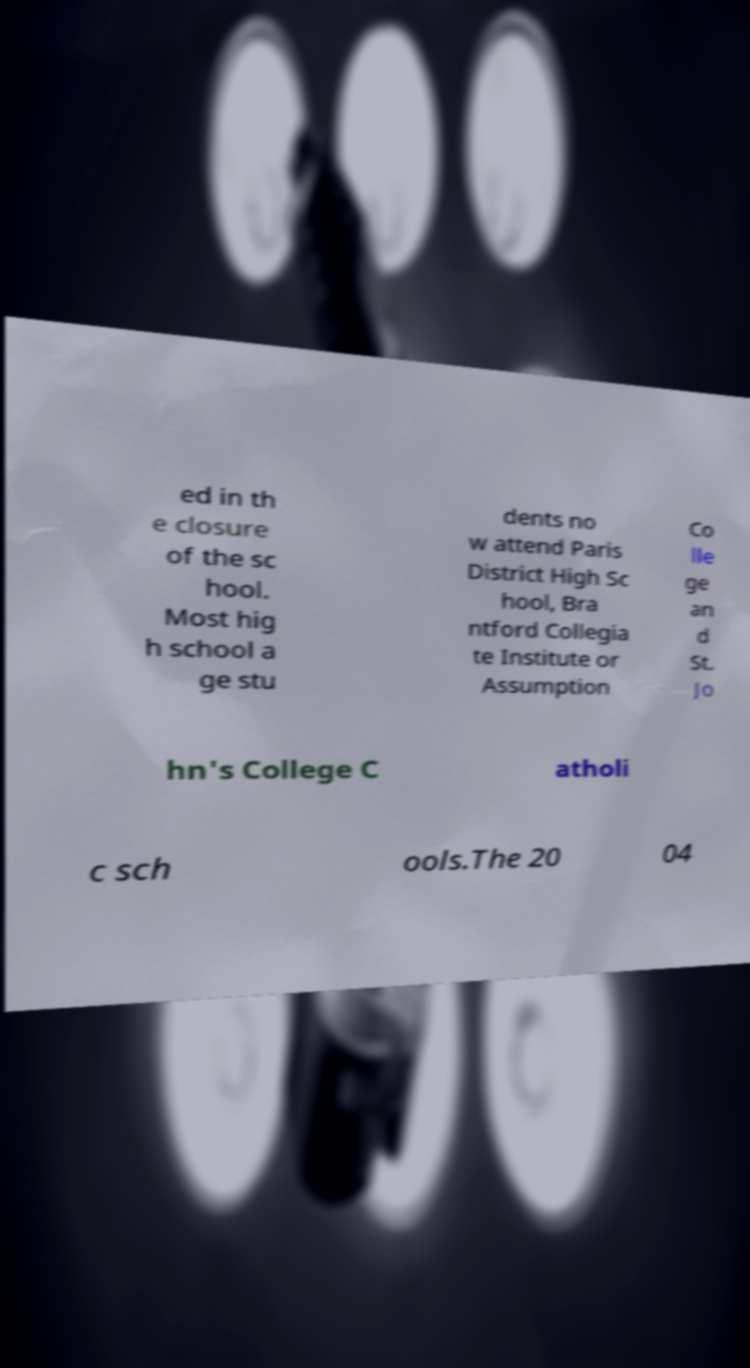I need the written content from this picture converted into text. Can you do that? ed in th e closure of the sc hool. Most hig h school a ge stu dents no w attend Paris District High Sc hool, Bra ntford Collegia te Institute or Assumption Co lle ge an d St. Jo hn's College C atholi c sch ools.The 20 04 